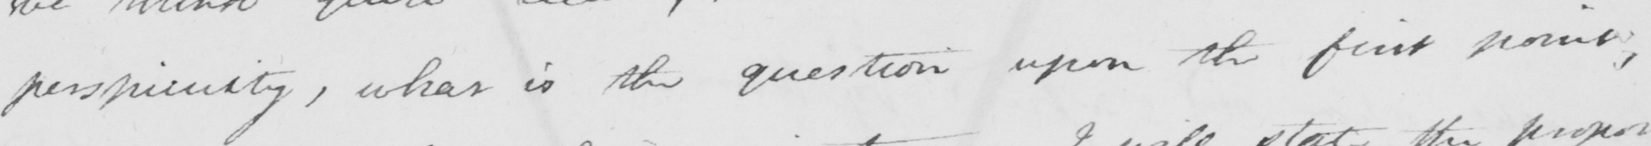Can you tell me what this handwritten text says? perspicuity , what is the question upon the first point , 